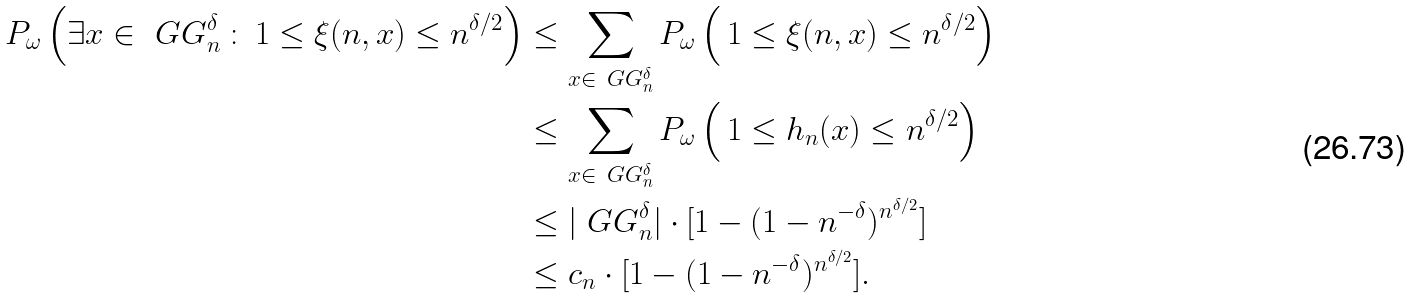<formula> <loc_0><loc_0><loc_500><loc_500>P _ { \omega } \left ( \exists x \in \ G G _ { n } ^ { \delta } \, \colon \, 1 \leq \xi ( n , x ) \leq n ^ { \delta / 2 } \right ) & \leq \sum _ { x \in \ G G _ { n } ^ { \delta } } P _ { \omega } \left ( \, 1 \leq \xi ( n , x ) \leq n ^ { \delta / 2 } \right ) \\ & \leq \sum _ { x \in \ G G _ { n } ^ { \delta } } P _ { \omega } \left ( \, 1 \leq h _ { n } ( x ) \leq n ^ { \delta / 2 } \right ) \\ & \leq | \ G G _ { n } ^ { \delta } | \cdot [ 1 - ( 1 - n ^ { - \delta } ) ^ { n ^ { \delta / 2 } } ] \\ & \leq c _ { n } \cdot [ 1 - ( 1 - n ^ { - \delta } ) ^ { n ^ { \delta / 2 } } ] .</formula> 